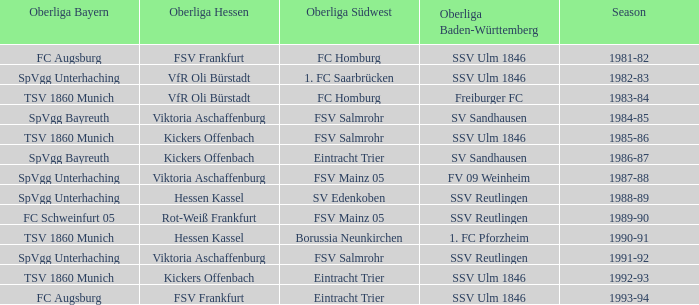During which season did spvgg bayreuth and eintracht trier face each other? 1986-87. 